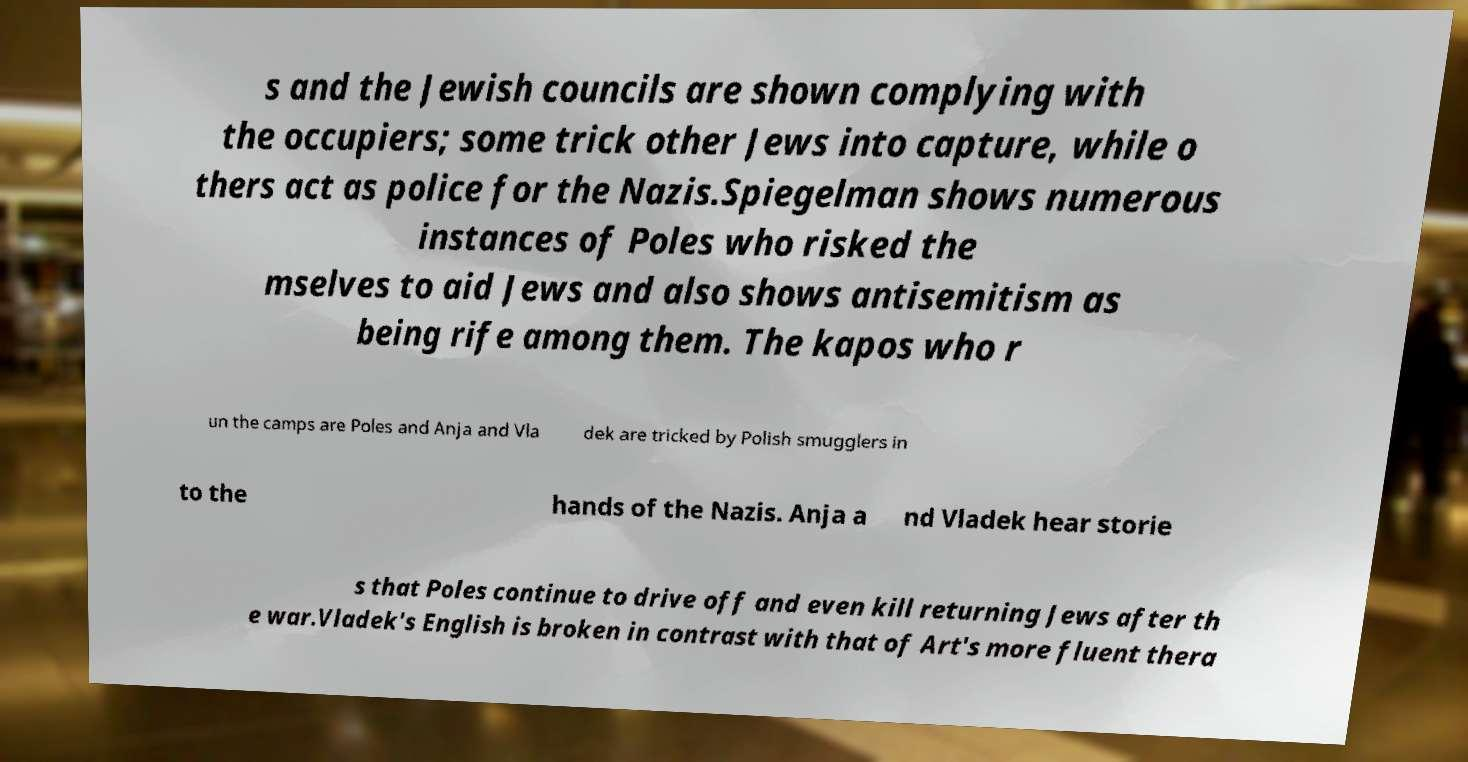For documentation purposes, I need the text within this image transcribed. Could you provide that? s and the Jewish councils are shown complying with the occupiers; some trick other Jews into capture, while o thers act as police for the Nazis.Spiegelman shows numerous instances of Poles who risked the mselves to aid Jews and also shows antisemitism as being rife among them. The kapos who r un the camps are Poles and Anja and Vla dek are tricked by Polish smugglers in to the hands of the Nazis. Anja a nd Vladek hear storie s that Poles continue to drive off and even kill returning Jews after th e war.Vladek's English is broken in contrast with that of Art's more fluent thera 